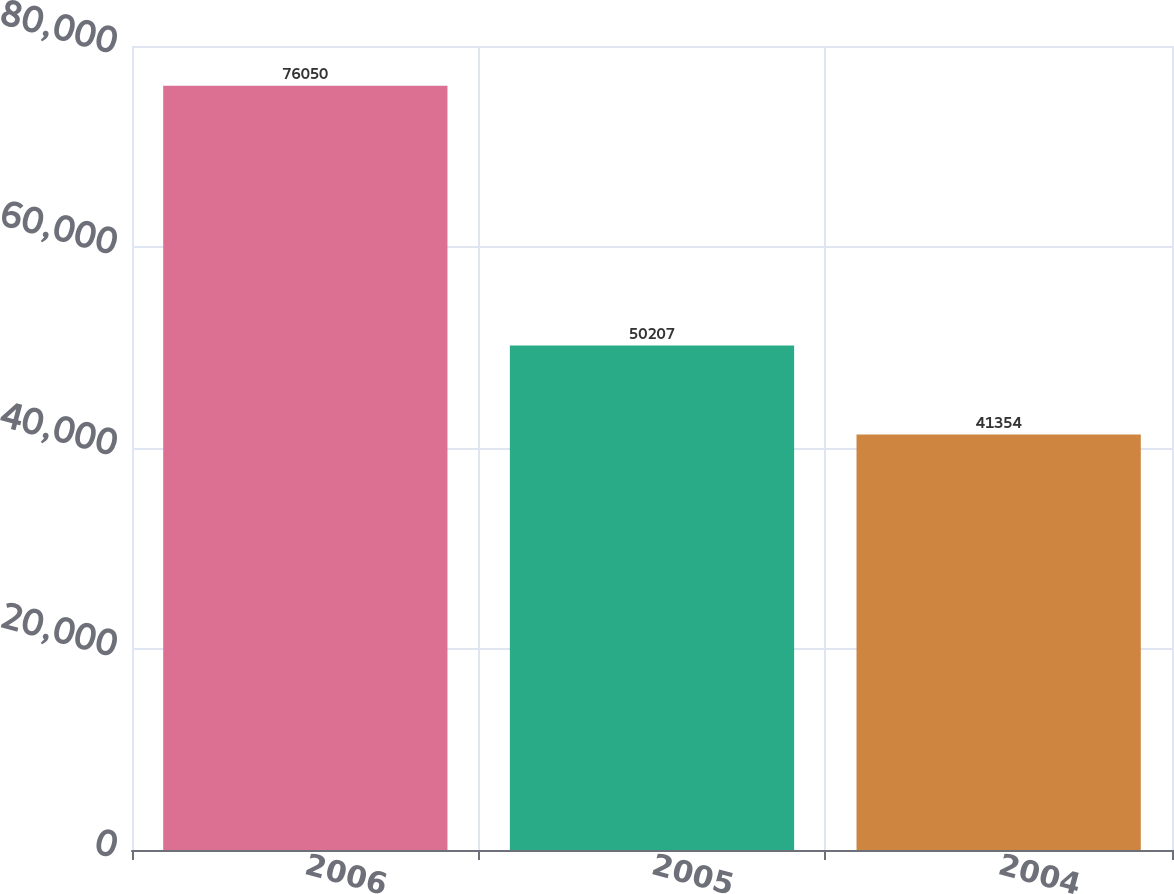Convert chart to OTSL. <chart><loc_0><loc_0><loc_500><loc_500><bar_chart><fcel>2006<fcel>2005<fcel>2004<nl><fcel>76050<fcel>50207<fcel>41354<nl></chart> 